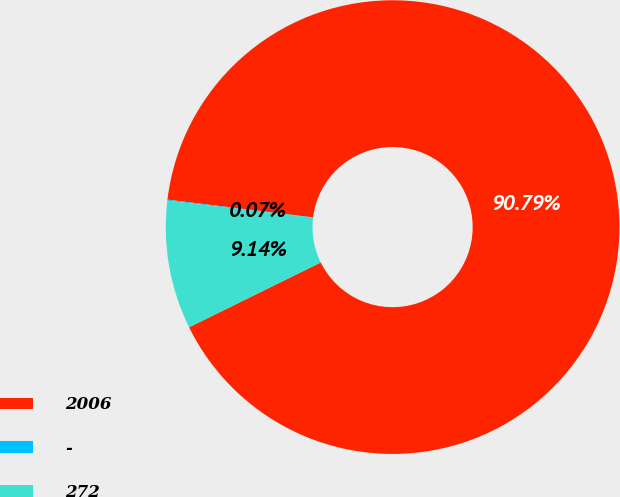Convert chart. <chart><loc_0><loc_0><loc_500><loc_500><pie_chart><fcel>2006<fcel>-<fcel>272<nl><fcel>90.79%<fcel>0.07%<fcel>9.14%<nl></chart> 